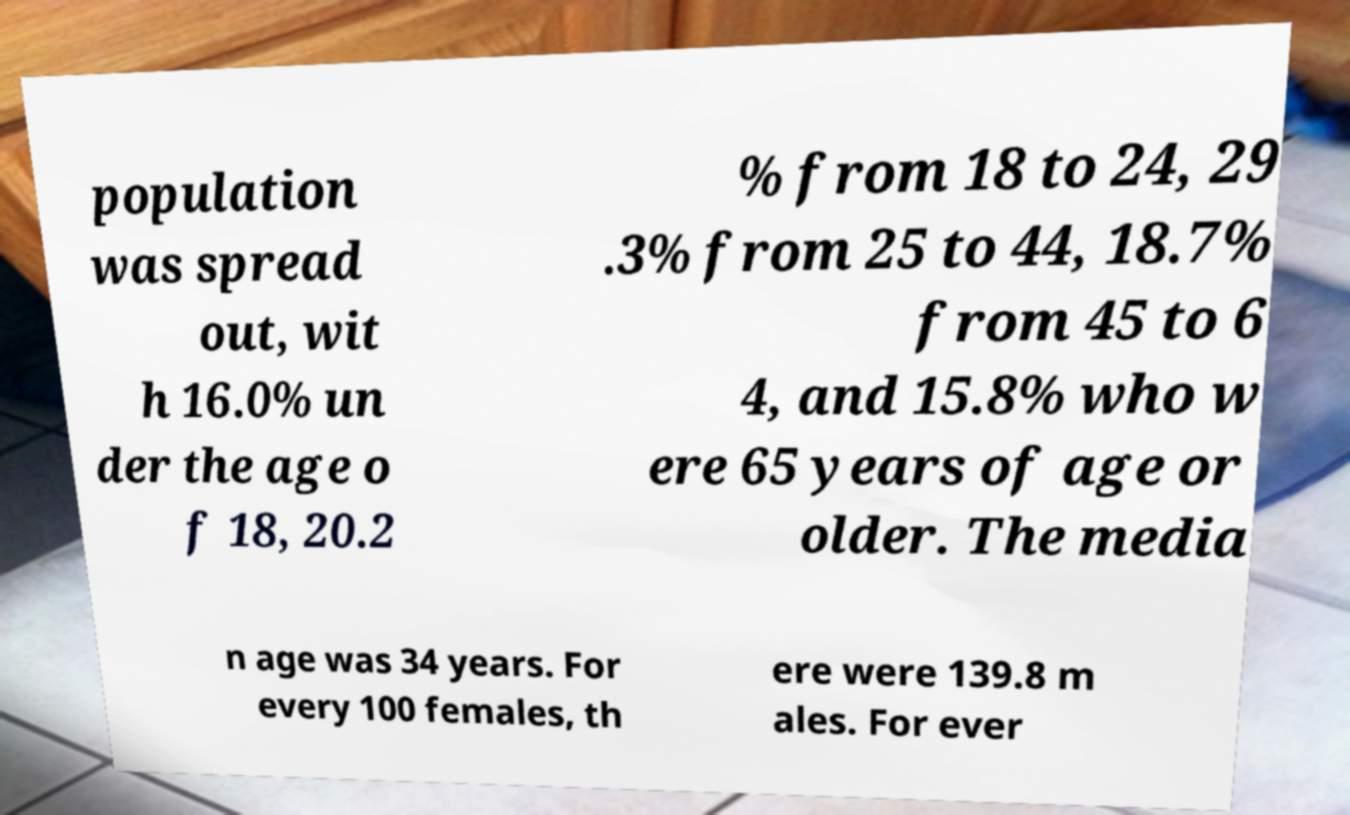Can you accurately transcribe the text from the provided image for me? population was spread out, wit h 16.0% un der the age o f 18, 20.2 % from 18 to 24, 29 .3% from 25 to 44, 18.7% from 45 to 6 4, and 15.8% who w ere 65 years of age or older. The media n age was 34 years. For every 100 females, th ere were 139.8 m ales. For ever 